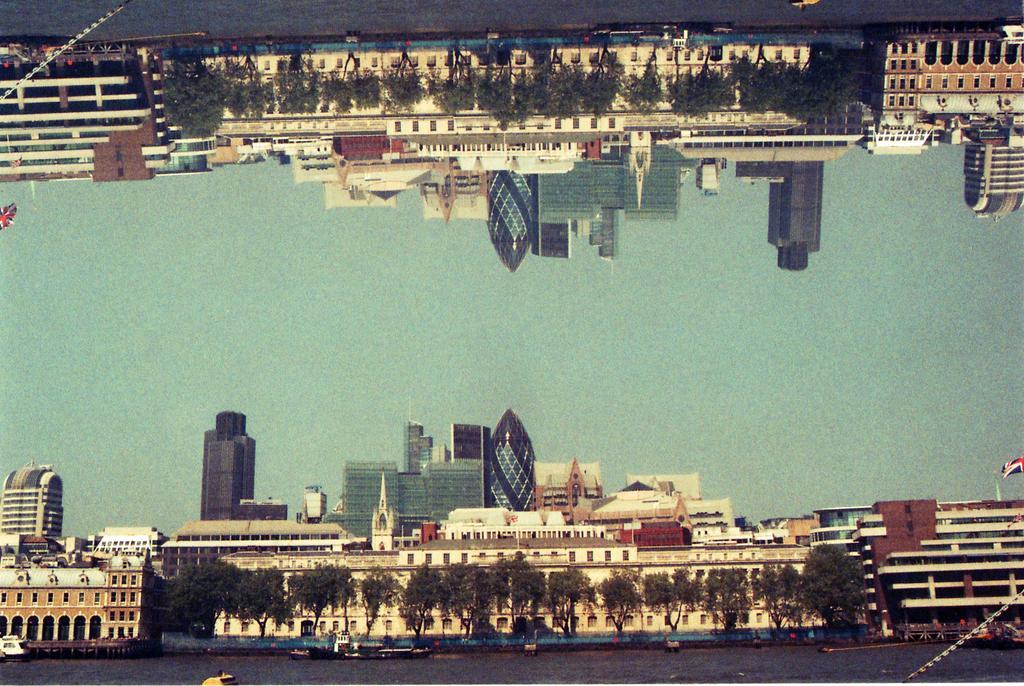Can you describe this image briefly? In this picture we can observe buildings. There are trees. We can observe water on which there is a boat. In the background there is a sky. We can observe the mirror image of the below building here. 